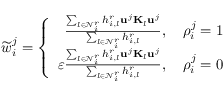<formula> <loc_0><loc_0><loc_500><loc_500>\widetilde { w } _ { i } ^ { j } = \left \{ \begin{array} { r } { \frac { \sum _ { l \in \mathcal { N } _ { i } ^ { r } } h _ { i , l } ^ { r } u ^ { j } K _ { l } u ^ { j } } { \sum _ { l \in \mathcal { N } _ { i } ^ { r } } h _ { i , l } ^ { r } } , \quad \rho _ { i } ^ { j } = 1 } \\ { \varepsilon \frac { \sum _ { l \in \mathcal { N } _ { i } ^ { r } } h _ { i , l } ^ { r } u ^ { j } K _ { l } u ^ { j } } { \sum _ { l \in \mathcal { N } _ { i } ^ { r } } h _ { i , l } ^ { r } } , \quad \rho _ { i } ^ { j } = 0 } \end{array}</formula> 